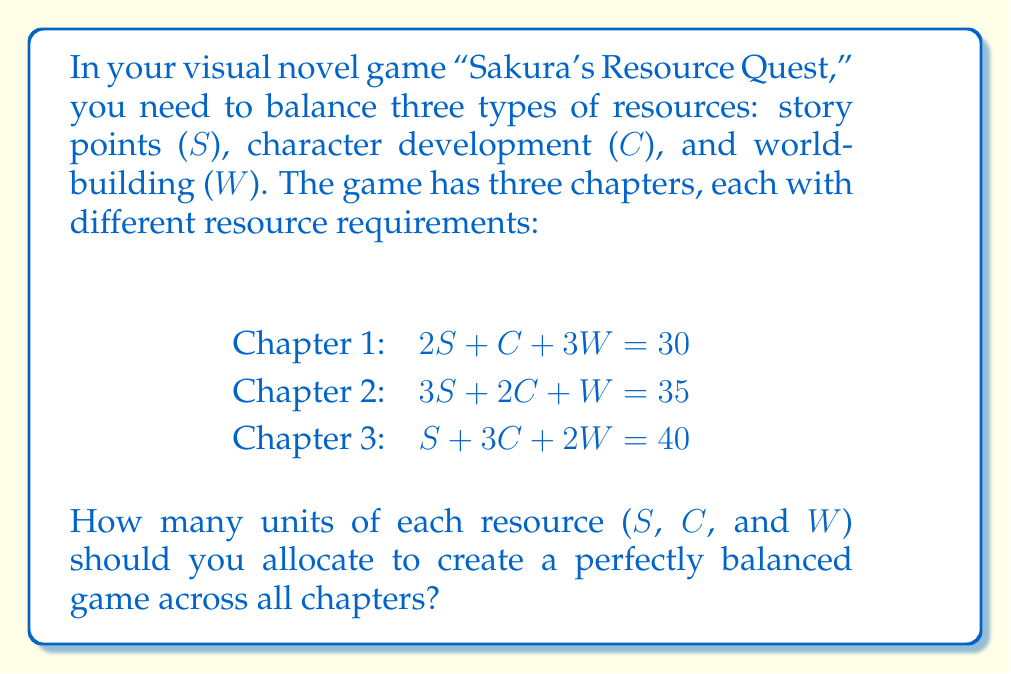Give your solution to this math problem. To solve this system of linear equations, we'll use the Gaussian elimination method:

1. Write the augmented matrix:
   $$\begin{bmatrix}
   2 & 1 & 3 & 30 \\
   3 & 2 & 1 & 35 \\
   1 & 3 & 2 & 40
   \end{bmatrix}$$

2. Multiply the first row by -3/2 and add it to the second row:
   $$\begin{bmatrix}
   2 & 1 & 3 & 30 \\
   0 & 1/2 & -7/2 & -10 \\
   1 & 3 & 2 & 40
   \end{bmatrix}$$

3. Multiply the first row by -1/2 and add it to the third row:
   $$\begin{bmatrix}
   2 & 1 & 3 & 30 \\
   0 & 1/2 & -7/2 & -10 \\
   0 & 5/2 & 1/2 & 25
   \end{bmatrix}$$

4. Multiply the second row by -5 and add it to the third row:
   $$\begin{bmatrix}
   2 & 1 & 3 & 30 \\
   0 & 1/2 & -7/2 & -10 \\
   0 & 0 & 18 & 75
   \end{bmatrix}$$

5. Back-substitute to find W:
   $18W = 75$
   $W = 75/18 = 25/6$

6. Substitute W into the second equation:
   $1/2C - 7/2(25/6) = -10$
   $1/2C - 29.17 = -10$
   $1/2C = 19.17$
   $C = 38.33$

7. Substitute W and C into the first equation:
   $2S + 38.33 + 3(25/6) = 30$
   $2S + 38.33 + 12.5 = 30$
   $2S = -20.83$
   $S = -10.42$

8. Round the results to the nearest whole number:
   $S = -10$
   $C = 38$
   $W = 4$
Answer: $S = -10, C = 38, W = 4$ 